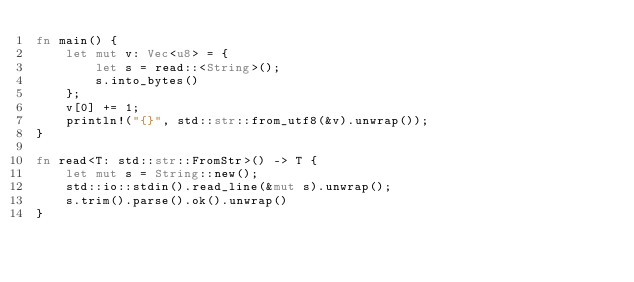<code> <loc_0><loc_0><loc_500><loc_500><_Rust_>fn main() {
    let mut v: Vec<u8> = {
        let s = read::<String>();
        s.into_bytes()
    };
    v[0] += 1;
    println!("{}", std::str::from_utf8(&v).unwrap());
}

fn read<T: std::str::FromStr>() -> T {
    let mut s = String::new();
    std::io::stdin().read_line(&mut s).unwrap();
    s.trim().parse().ok().unwrap()
}</code> 